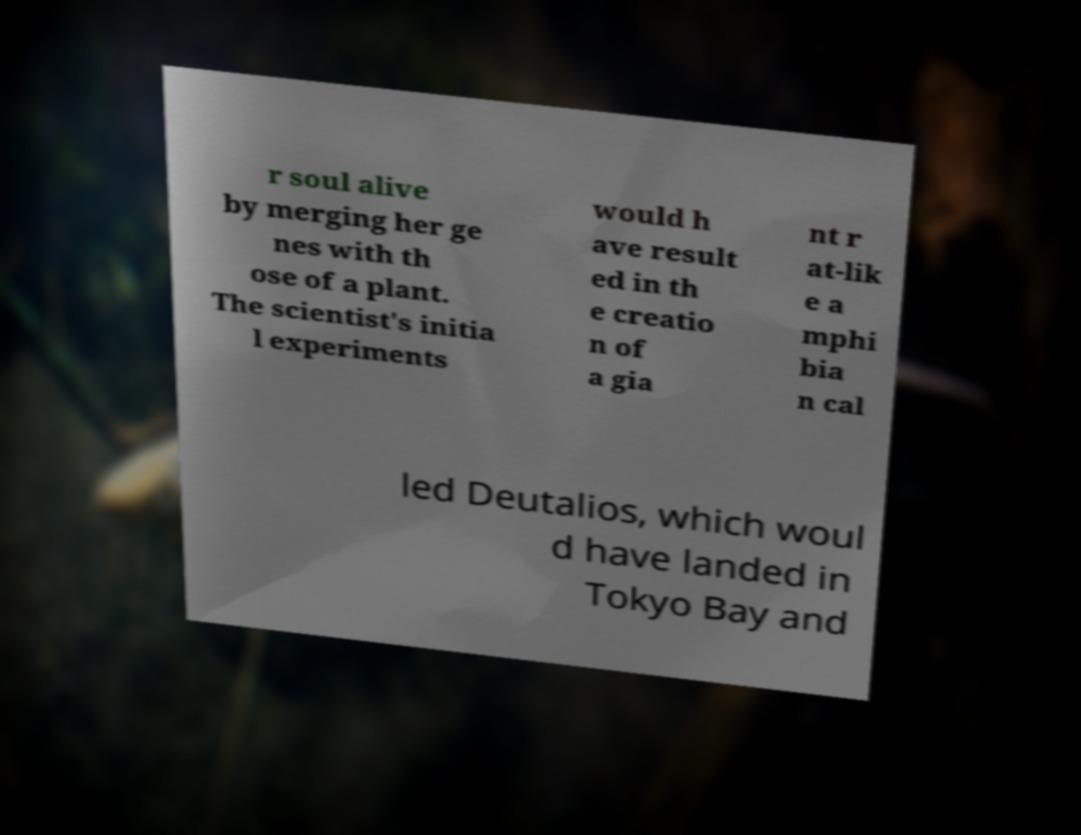Please read and relay the text visible in this image. What does it say? r soul alive by merging her ge nes with th ose of a plant. The scientist's initia l experiments would h ave result ed in th e creatio n of a gia nt r at-lik e a mphi bia n cal led Deutalios, which woul d have landed in Tokyo Bay and 